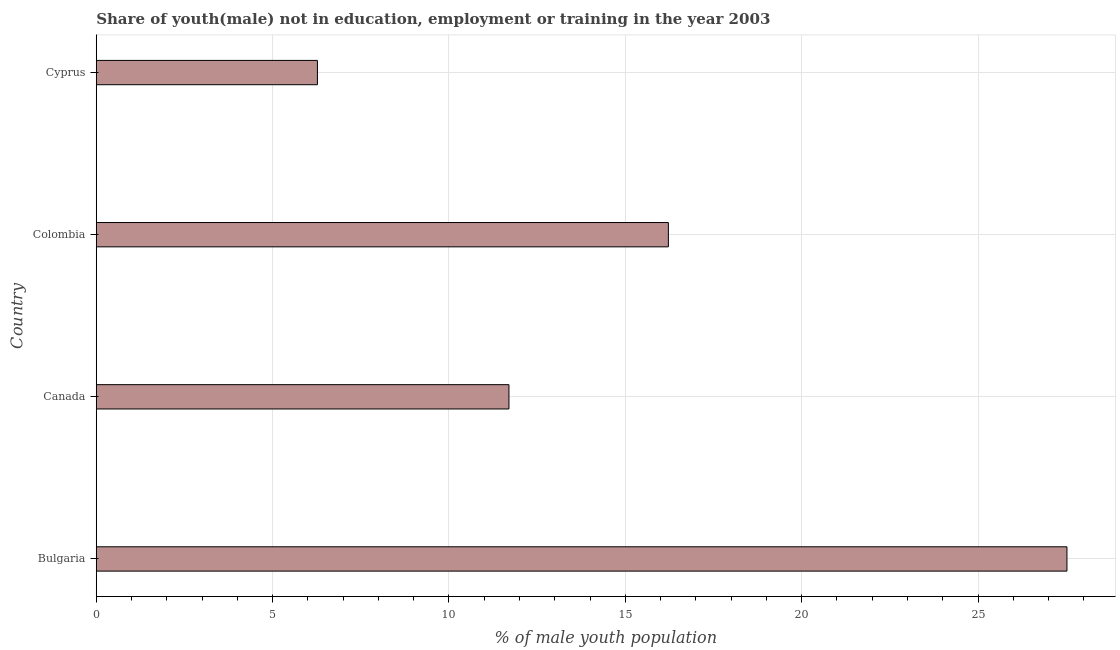What is the title of the graph?
Provide a short and direct response. Share of youth(male) not in education, employment or training in the year 2003. What is the label or title of the X-axis?
Your answer should be very brief. % of male youth population. What is the label or title of the Y-axis?
Provide a succinct answer. Country. What is the unemployed male youth population in Bulgaria?
Offer a terse response. 27.52. Across all countries, what is the maximum unemployed male youth population?
Ensure brevity in your answer.  27.52. Across all countries, what is the minimum unemployed male youth population?
Provide a succinct answer. 6.27. In which country was the unemployed male youth population minimum?
Offer a very short reply. Cyprus. What is the sum of the unemployed male youth population?
Provide a succinct answer. 61.71. What is the difference between the unemployed male youth population in Colombia and Cyprus?
Offer a terse response. 9.95. What is the average unemployed male youth population per country?
Your answer should be very brief. 15.43. What is the median unemployed male youth population?
Provide a succinct answer. 13.96. In how many countries, is the unemployed male youth population greater than 13 %?
Keep it short and to the point. 2. What is the ratio of the unemployed male youth population in Bulgaria to that in Canada?
Offer a terse response. 2.35. Is the unemployed male youth population in Canada less than that in Cyprus?
Ensure brevity in your answer.  No. Is the sum of the unemployed male youth population in Bulgaria and Colombia greater than the maximum unemployed male youth population across all countries?
Make the answer very short. Yes. What is the difference between the highest and the lowest unemployed male youth population?
Ensure brevity in your answer.  21.25. In how many countries, is the unemployed male youth population greater than the average unemployed male youth population taken over all countries?
Keep it short and to the point. 2. How many bars are there?
Provide a short and direct response. 4. How many countries are there in the graph?
Offer a very short reply. 4. What is the difference between two consecutive major ticks on the X-axis?
Make the answer very short. 5. What is the % of male youth population of Bulgaria?
Keep it short and to the point. 27.52. What is the % of male youth population in Canada?
Offer a very short reply. 11.7. What is the % of male youth population of Colombia?
Offer a very short reply. 16.22. What is the % of male youth population in Cyprus?
Provide a short and direct response. 6.27. What is the difference between the % of male youth population in Bulgaria and Canada?
Your answer should be compact. 15.82. What is the difference between the % of male youth population in Bulgaria and Colombia?
Make the answer very short. 11.3. What is the difference between the % of male youth population in Bulgaria and Cyprus?
Offer a very short reply. 21.25. What is the difference between the % of male youth population in Canada and Colombia?
Your answer should be very brief. -4.52. What is the difference between the % of male youth population in Canada and Cyprus?
Your answer should be compact. 5.43. What is the difference between the % of male youth population in Colombia and Cyprus?
Offer a very short reply. 9.95. What is the ratio of the % of male youth population in Bulgaria to that in Canada?
Offer a very short reply. 2.35. What is the ratio of the % of male youth population in Bulgaria to that in Colombia?
Provide a short and direct response. 1.7. What is the ratio of the % of male youth population in Bulgaria to that in Cyprus?
Offer a very short reply. 4.39. What is the ratio of the % of male youth population in Canada to that in Colombia?
Your response must be concise. 0.72. What is the ratio of the % of male youth population in Canada to that in Cyprus?
Keep it short and to the point. 1.87. What is the ratio of the % of male youth population in Colombia to that in Cyprus?
Offer a very short reply. 2.59. 